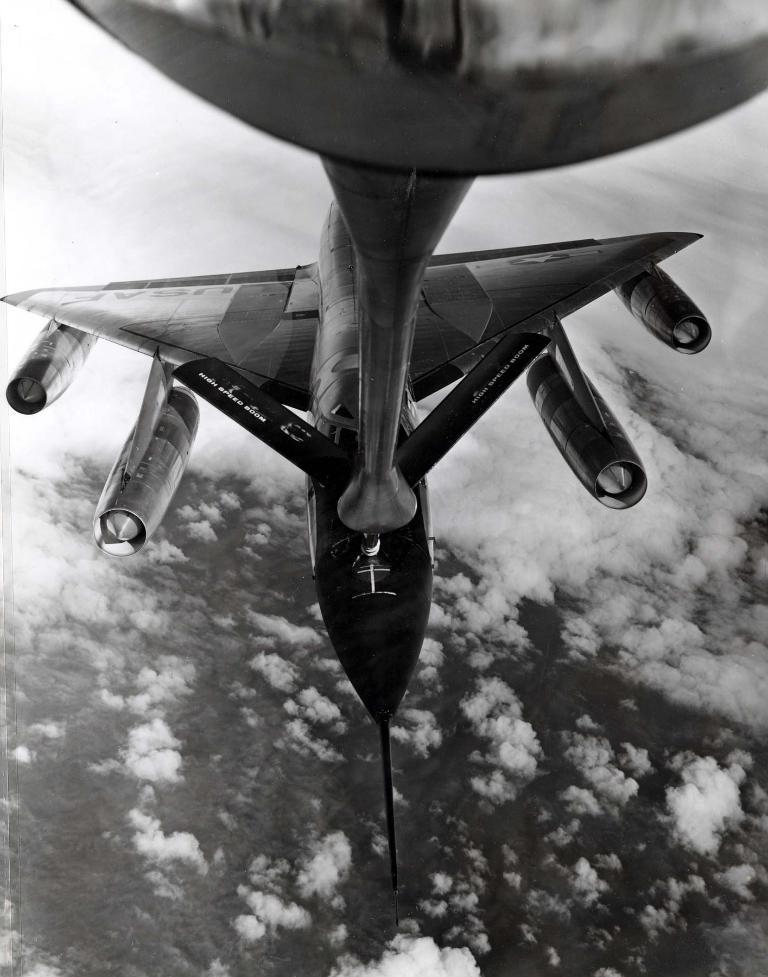How would you summarize this image in a sentence or two? This is a black and white image. I think this is an airplane flying in the sky. These are the clouds. 